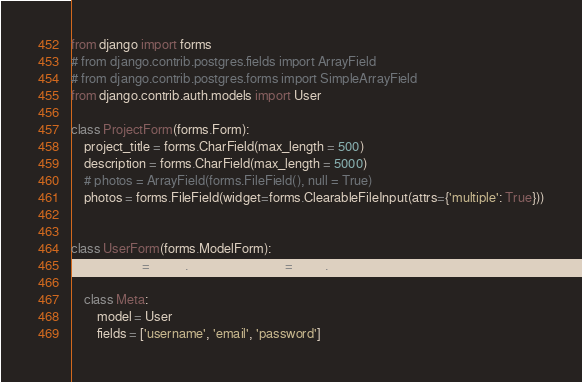Convert code to text. <code><loc_0><loc_0><loc_500><loc_500><_Python_>from django import forms
# from django.contrib.postgres.fields import ArrayField
# from django.contrib.postgres.forms import SimpleArrayField
from django.contrib.auth.models import User

class ProjectForm(forms.Form):
	project_title = forms.CharField(max_length = 500)
	description = forms.CharField(max_length = 5000)
	# photos = ArrayField(forms.FileField(), null = True)
	photos = forms.FileField(widget=forms.ClearableFileInput(attrs={'multiple': True}))


class UserForm(forms.ModelForm):
	password = forms.CharField(widget=forms.PasswordInput)

	class Meta:
		model = User
		fields = ['username', 'email', 'password']
</code> 